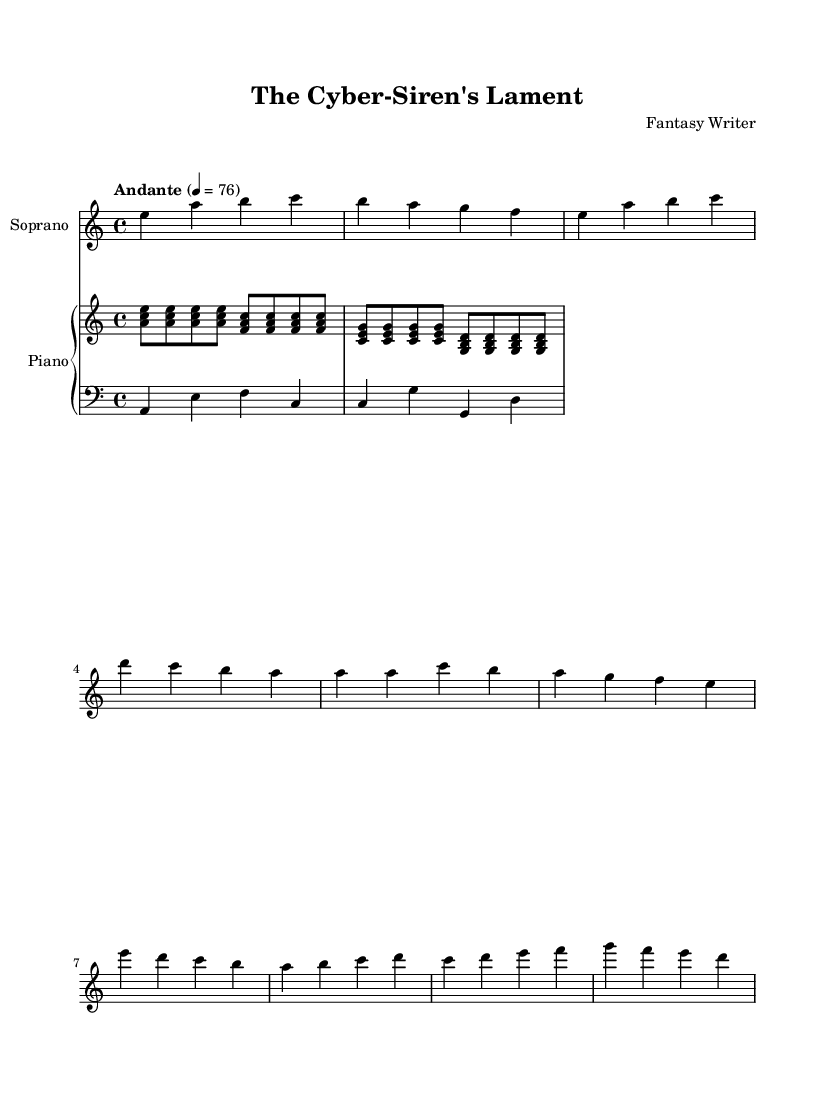What is the key signature of this music? The key signature of this piece is A minor, which has no sharps or flats.
Answer: A minor What is the time signature of this music? The time signature indicated at the start of the piece is 4/4, meaning there are four beats in each measure.
Answer: 4/4 What is the tempo marking given? The tempo marking is "Andante", which indicates a moderate walking pace.
Answer: Andante How many measures are shown in the soprano part? Counting the measures in the soprano part, there are a total of 10 measures present.
Answer: 10 What is the musical form of the defined sections in the piece? The structure includes an introduction, a verse, a chorus, and a bridge, resembling a verse-chorus form.
Answer: Verse-Chorus What instruments are featured in this score? The instruments indicated in this score are Soprano and Piano (which includes both right and left hand parts).
Answer: Soprano and Piano What is the harmonic texture of the piano part? The piano part is characterized by an arpeggiated texture in the right hand, combined with a simplified bass line in the left hand.
Answer: Arpeggiated 